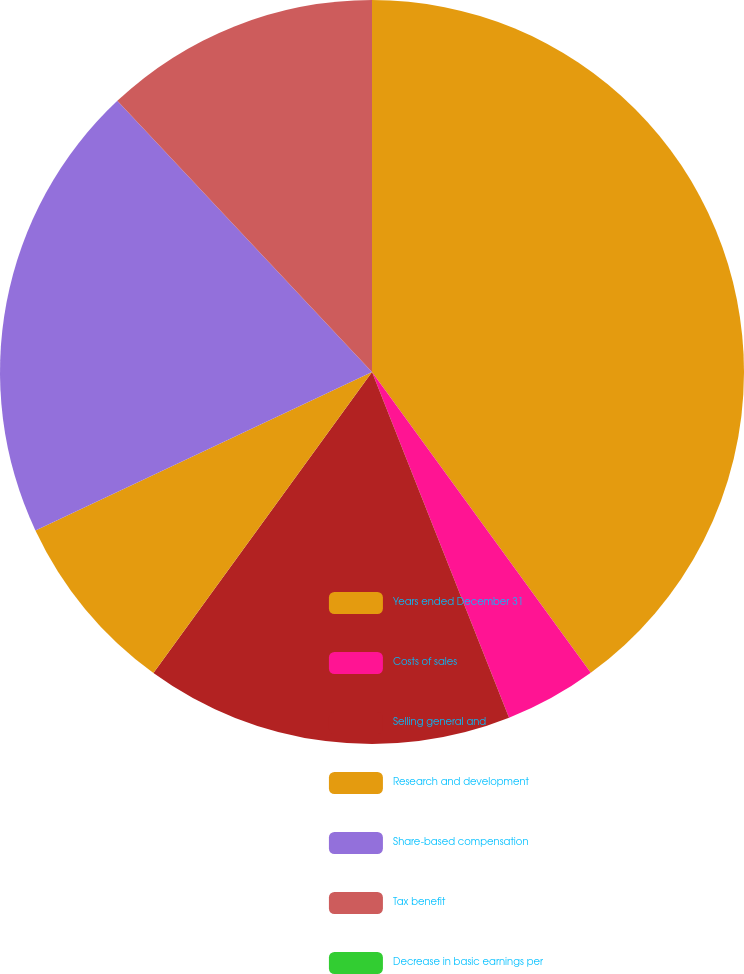Convert chart. <chart><loc_0><loc_0><loc_500><loc_500><pie_chart><fcel>Years ended December 31<fcel>Costs of sales<fcel>Selling general and<fcel>Research and development<fcel>Share-based compensation<fcel>Tax benefit<fcel>Decrease in basic earnings per<nl><fcel>39.99%<fcel>4.0%<fcel>16.0%<fcel>8.0%<fcel>20.0%<fcel>12.0%<fcel>0.0%<nl></chart> 